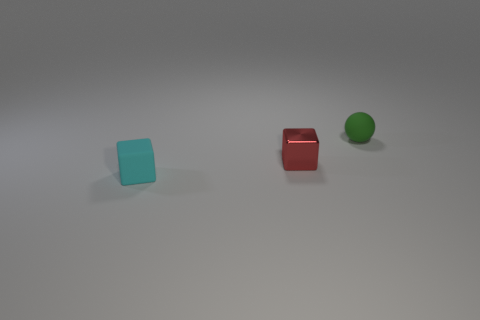Add 1 yellow things. How many objects exist? 4 Subtract all spheres. How many objects are left? 2 Subtract all small red shiny blocks. Subtract all metallic objects. How many objects are left? 1 Add 2 tiny red blocks. How many tiny red blocks are left? 3 Add 2 purple matte cubes. How many purple matte cubes exist? 2 Subtract 0 cyan balls. How many objects are left? 3 